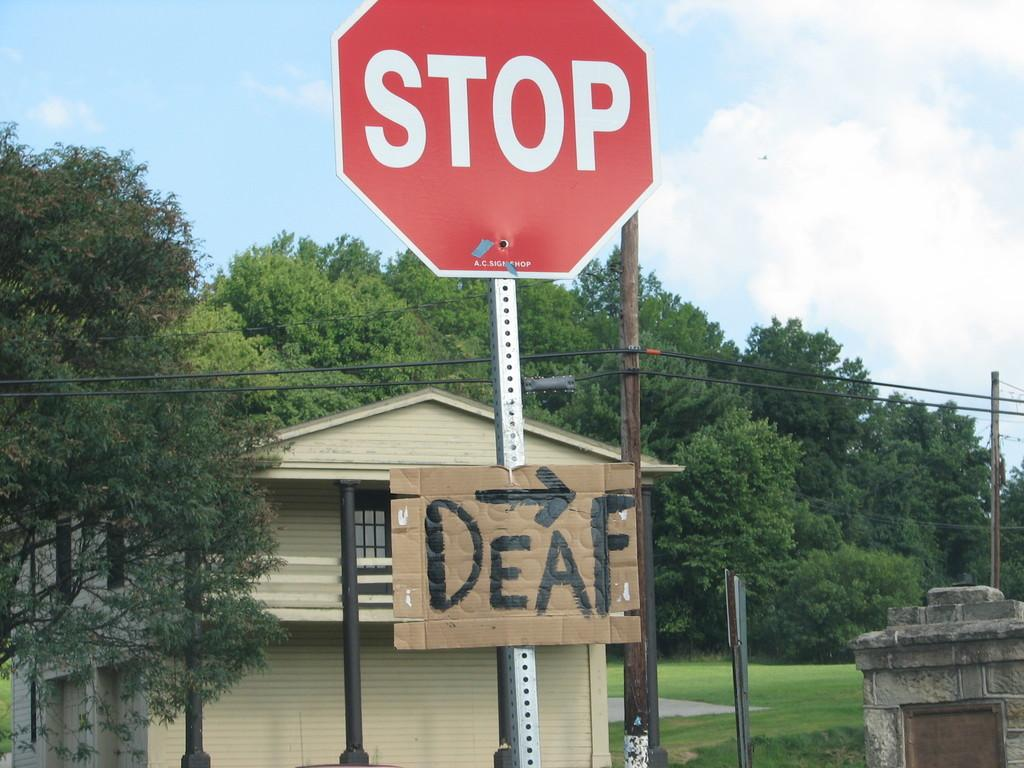<image>
Create a compact narrative representing the image presented. A red stop sign has a cardboard sign beneath it that says Deaf. 